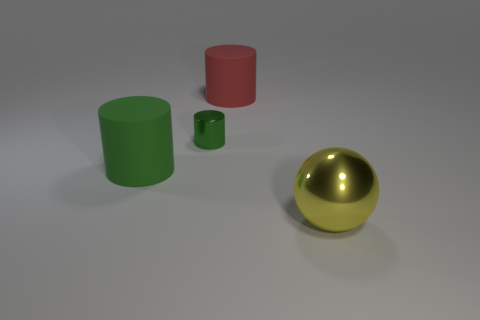What time of day could this scene represent based on the lighting? The scene is likely depicting an indoor setting with controlled lighting conditions, so it doesn't indicate a specific time of day. 